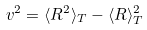Convert formula to latex. <formula><loc_0><loc_0><loc_500><loc_500>v ^ { 2 } = \langle R ^ { 2 } \rangle _ { T } - \langle R \rangle _ { T } ^ { 2 }</formula> 